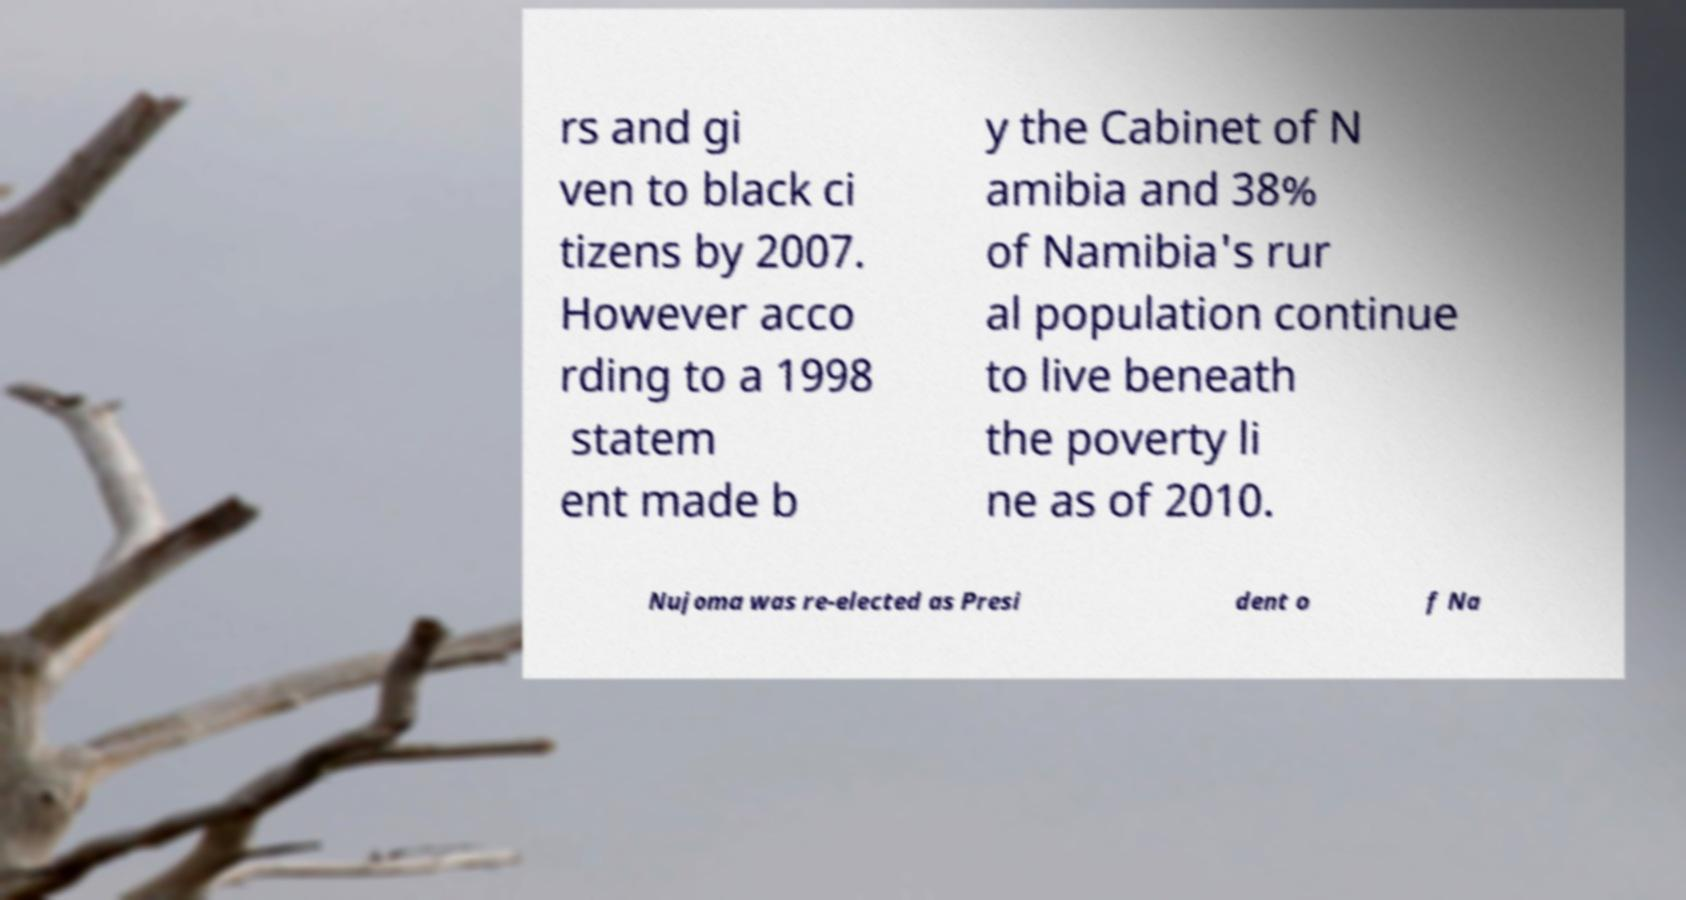Could you extract and type out the text from this image? rs and gi ven to black ci tizens by 2007. However acco rding to a 1998 statem ent made b y the Cabinet of N amibia and 38% of Namibia's rur al population continue to live beneath the poverty li ne as of 2010. Nujoma was re-elected as Presi dent o f Na 